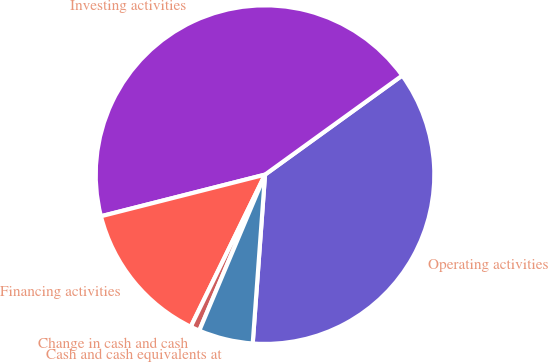Convert chart. <chart><loc_0><loc_0><loc_500><loc_500><pie_chart><fcel>Operating activities<fcel>Investing activities<fcel>Financing activities<fcel>Change in cash and cash<fcel>Cash and cash equivalents at<nl><fcel>36.12%<fcel>44.0%<fcel>13.82%<fcel>0.88%<fcel>5.19%<nl></chart> 